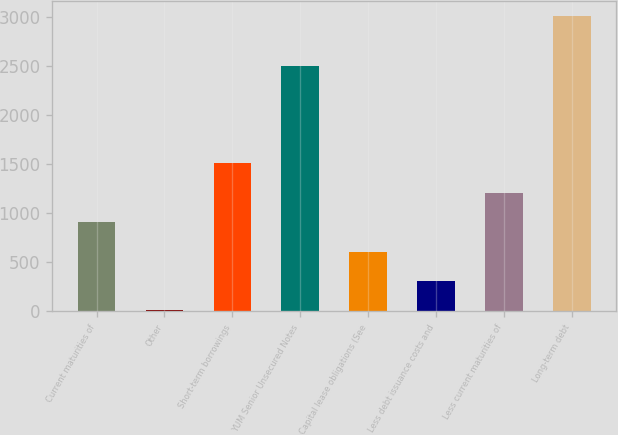<chart> <loc_0><loc_0><loc_500><loc_500><bar_chart><fcel>Current maturities of<fcel>Other<fcel>Short-term borrowings<fcel>YUM Senior Unsecured Notes<fcel>Capital lease obligations (See<fcel>Less debt issuance costs and<fcel>Less current maturities of<fcel>Long-term debt<nl><fcel>908.4<fcel>9<fcel>1508<fcel>2500<fcel>608.6<fcel>308.8<fcel>1208.2<fcel>3007<nl></chart> 